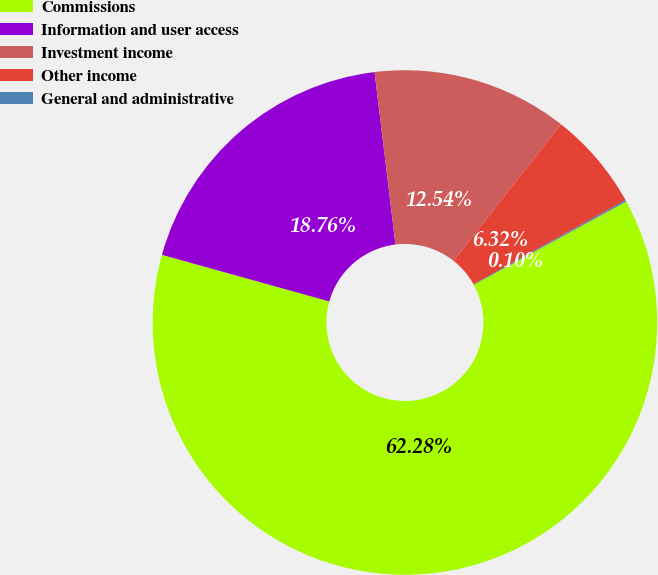Convert chart to OTSL. <chart><loc_0><loc_0><loc_500><loc_500><pie_chart><fcel>Commissions<fcel>Information and user access<fcel>Investment income<fcel>Other income<fcel>General and administrative<nl><fcel>62.29%<fcel>18.76%<fcel>12.54%<fcel>6.32%<fcel>0.1%<nl></chart> 